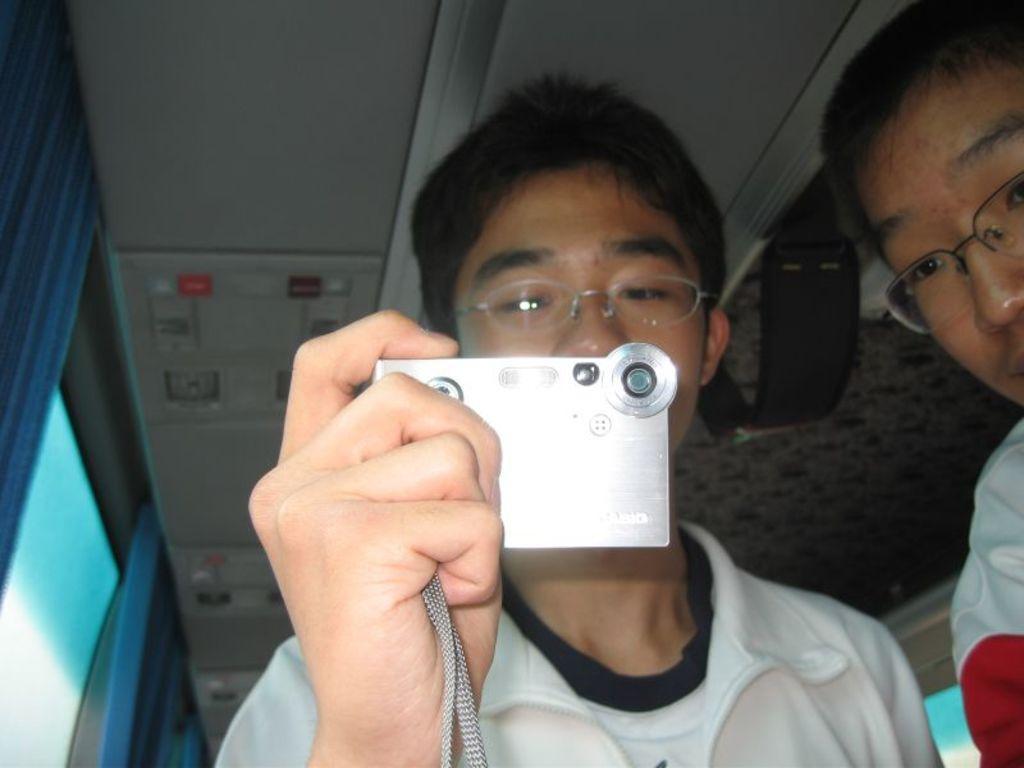In one or two sentences, can you explain what this image depicts? In this image I can see two men and I can see both of them are wearing specs. Here I can see he is holding a camera. In background I can see blue colour curtains and I can see this image is little bit blurry from background. Here I can see both of them are wearing white dress. 